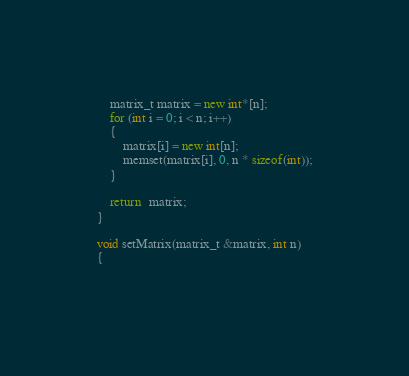Convert code to text. <code><loc_0><loc_0><loc_500><loc_500><_C++_>	matrix_t matrix = new int*[n];
	for (int i = 0; i < n; i++)
	{
		matrix[i] = new int[n];
		memset(matrix[i], 0, n * sizeof(int));
	}

	return  matrix;
}

void setMatrix(matrix_t &matrix, int n)
{
	</code> 